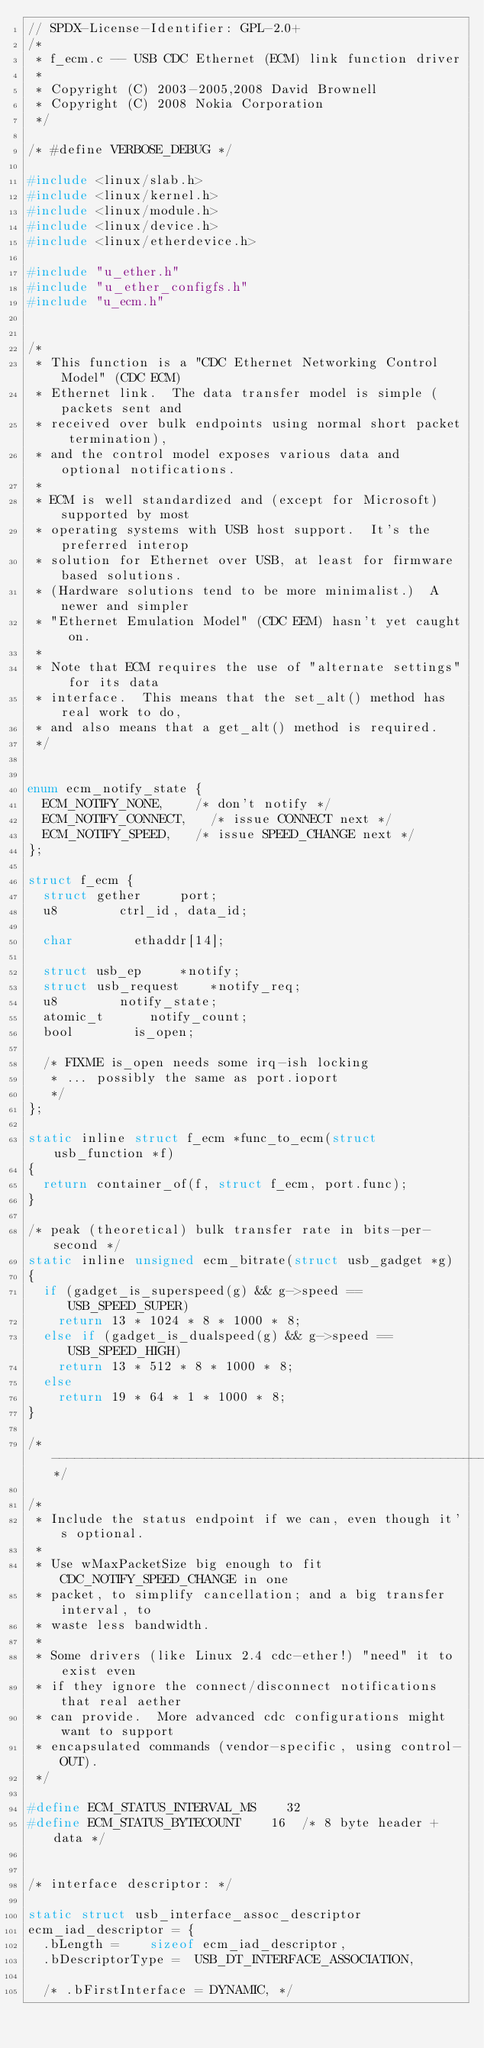Convert code to text. <code><loc_0><loc_0><loc_500><loc_500><_C_>// SPDX-License-Identifier: GPL-2.0+
/*
 * f_ecm.c -- USB CDC Ethernet (ECM) link function driver
 *
 * Copyright (C) 2003-2005,2008 David Brownell
 * Copyright (C) 2008 Nokia Corporation
 */

/* #define VERBOSE_DEBUG */

#include <linux/slab.h>
#include <linux/kernel.h>
#include <linux/module.h>
#include <linux/device.h>
#include <linux/etherdevice.h>

#include "u_ether.h"
#include "u_ether_configfs.h"
#include "u_ecm.h"


/*
 * This function is a "CDC Ethernet Networking Control Model" (CDC ECM)
 * Ethernet link.  The data transfer model is simple (packets sent and
 * received over bulk endpoints using normal short packet termination),
 * and the control model exposes various data and optional notifications.
 *
 * ECM is well standardized and (except for Microsoft) supported by most
 * operating systems with USB host support.  It's the preferred interop
 * solution for Ethernet over USB, at least for firmware based solutions.
 * (Hardware solutions tend to be more minimalist.)  A newer and simpler
 * "Ethernet Emulation Model" (CDC EEM) hasn't yet caught on.
 *
 * Note that ECM requires the use of "alternate settings" for its data
 * interface.  This means that the set_alt() method has real work to do,
 * and also means that a get_alt() method is required.
 */


enum ecm_notify_state {
	ECM_NOTIFY_NONE,		/* don't notify */
	ECM_NOTIFY_CONNECT,		/* issue CONNECT next */
	ECM_NOTIFY_SPEED,		/* issue SPEED_CHANGE next */
};

struct f_ecm {
	struct gether			port;
	u8				ctrl_id, data_id;

	char				ethaddr[14];

	struct usb_ep			*notify;
	struct usb_request		*notify_req;
	u8				notify_state;
	atomic_t			notify_count;
	bool				is_open;

	/* FIXME is_open needs some irq-ish locking
	 * ... possibly the same as port.ioport
	 */
};

static inline struct f_ecm *func_to_ecm(struct usb_function *f)
{
	return container_of(f, struct f_ecm, port.func);
}

/* peak (theoretical) bulk transfer rate in bits-per-second */
static inline unsigned ecm_bitrate(struct usb_gadget *g)
{
	if (gadget_is_superspeed(g) && g->speed == USB_SPEED_SUPER)
		return 13 * 1024 * 8 * 1000 * 8;
	else if (gadget_is_dualspeed(g) && g->speed == USB_SPEED_HIGH)
		return 13 * 512 * 8 * 1000 * 8;
	else
		return 19 * 64 * 1 * 1000 * 8;
}

/*-------------------------------------------------------------------------*/

/*
 * Include the status endpoint if we can, even though it's optional.
 *
 * Use wMaxPacketSize big enough to fit CDC_NOTIFY_SPEED_CHANGE in one
 * packet, to simplify cancellation; and a big transfer interval, to
 * waste less bandwidth.
 *
 * Some drivers (like Linux 2.4 cdc-ether!) "need" it to exist even
 * if they ignore the connect/disconnect notifications that real aether
 * can provide.  More advanced cdc configurations might want to support
 * encapsulated commands (vendor-specific, using control-OUT).
 */

#define ECM_STATUS_INTERVAL_MS		32
#define ECM_STATUS_BYTECOUNT		16	/* 8 byte header + data */


/* interface descriptor: */

static struct usb_interface_assoc_descriptor
ecm_iad_descriptor = {
	.bLength =		sizeof ecm_iad_descriptor,
	.bDescriptorType =	USB_DT_INTERFACE_ASSOCIATION,

	/* .bFirstInterface =	DYNAMIC, */</code> 